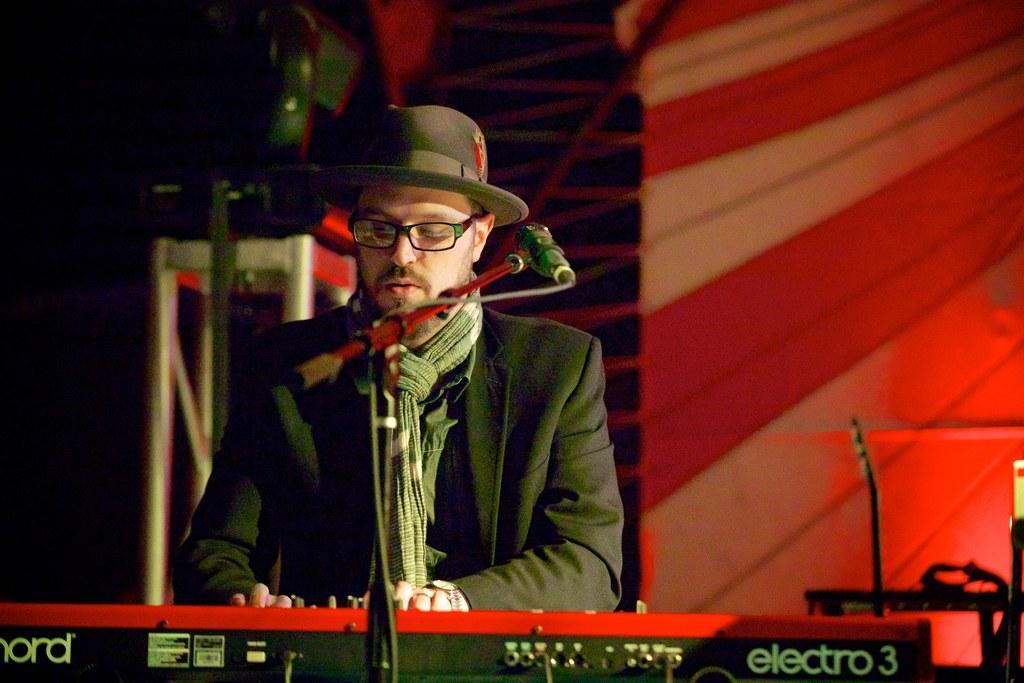What is the man in the image doing? The man is singing on a microphone and playing a piano. What is the man wearing in the image? The man is wearing a suit and hat. Where is the scene taking place? The scene appears to be on a stage. What can be seen behind the man? There is a cloth banner behind the man. What accessory is the man wearing around his neck? The man has a scarf around his neck. What sound does the chicken make while the man is singing on stage? There is no chicken present in the image, so it is not possible to determine the sound it might make. 